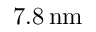Convert formula to latex. <formula><loc_0><loc_0><loc_500><loc_500>7 . 8 \, n m</formula> 